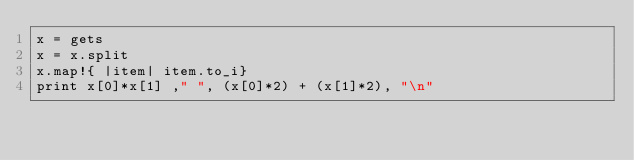<code> <loc_0><loc_0><loc_500><loc_500><_Ruby_>x = gets
x = x.split
x.map!{ |item| item.to_i}
print x[0]*x[1] ," ", (x[0]*2) + (x[1]*2), "\n" </code> 